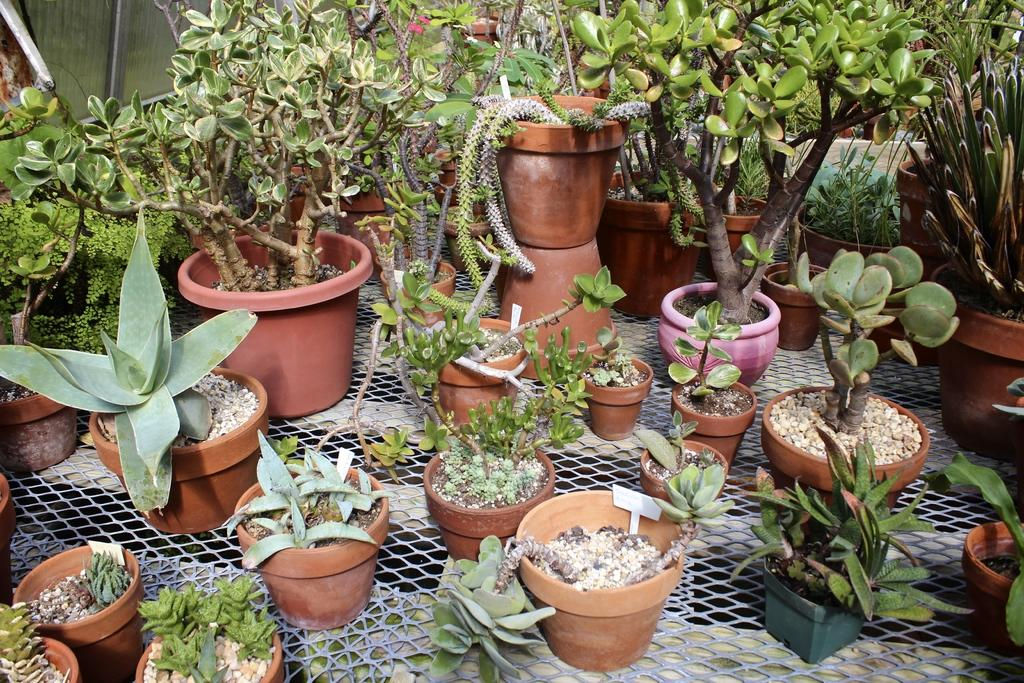What type of plants are visible in the image? There are plants on a mesh in the image. Can you describe the arrangement of the plants in the image? The plants are arranged on a mesh. How does the boy interact with the plants on the mesh in the image? There is no boy present in the image, so it is not possible to answer how a boy might interact with the plants. 